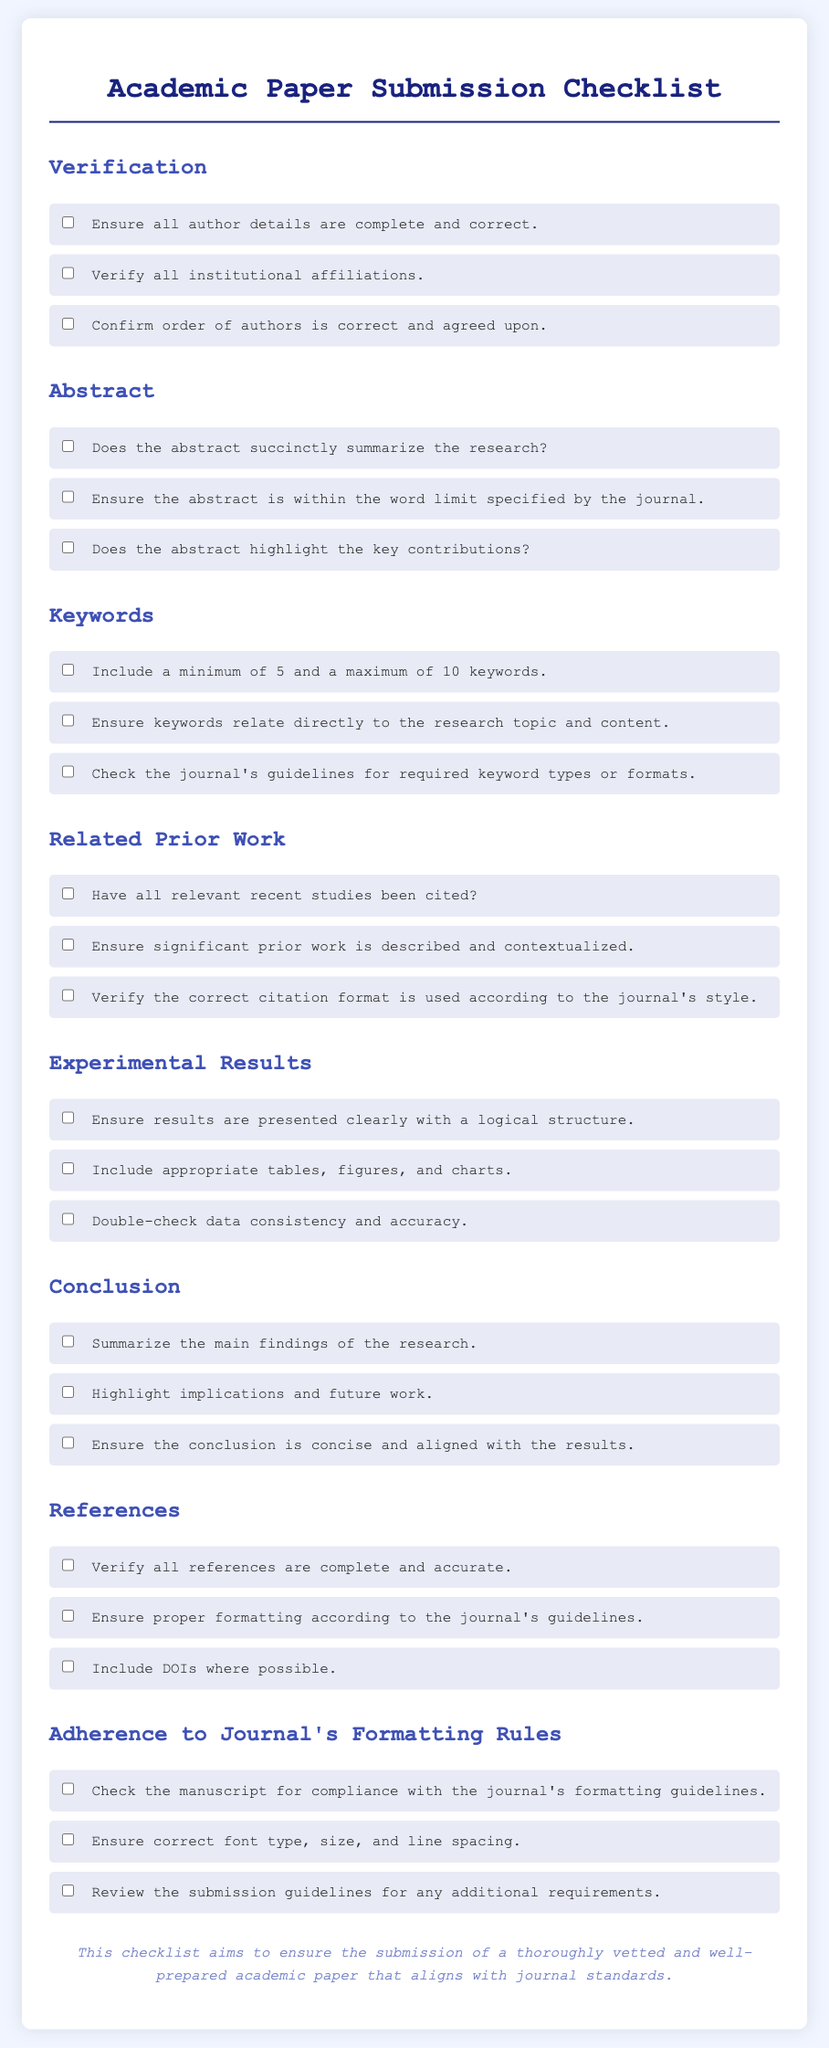What are the sections included in the checklist? The sections mentioned in the checklist are Verification, Abstract, Keywords, Related Prior Work, Experimental Results, Conclusion, References, and Adherence to Journal's Formatting Rules.
Answer: Verification, Abstract, Keywords, Related Prior Work, Experimental Results, Conclusion, References, Adherence to Journal's Formatting Rules How many keywords should be included? The checklist specifies a minimum and maximum requirement for keywords, stating that a minimum of 5 and a maximum of 10 keywords must be included.
Answer: 5 to 10 keywords What does the abstract need to highlight? The checklist indicates that the abstract should highlight the key contributions of the research.
Answer: Key contributions What must be verified regarding author details? The checklist states that all author details should be complete and correct.
Answer: Complete and correct What should be included in the conclusions? The conclusion section should summarize the main findings of the research as per the checklist.
Answer: Main findings Are DOIs required for references? The checklist mentions that including DOIs where possible is recommended in the references section.
Answer: Yes What is the main purpose of the checklist? The checklist aims to ensure the submission of a thoroughly vetted and well-prepared academic paper that aligns with journal standards.
Answer: Ensure thorough vetting What type of format checks are required for the manuscript? The checklist requires checking the manuscript for compliance with the journal's formatting guidelines, which includes font type, size, and line spacing.
Answer: Compliance with formatting guidelines How should results be presented? The checklist advises that results should be presented clearly with a logical structure, including appropriate tables, figures, and charts.
Answer: Clearly with logical structure 